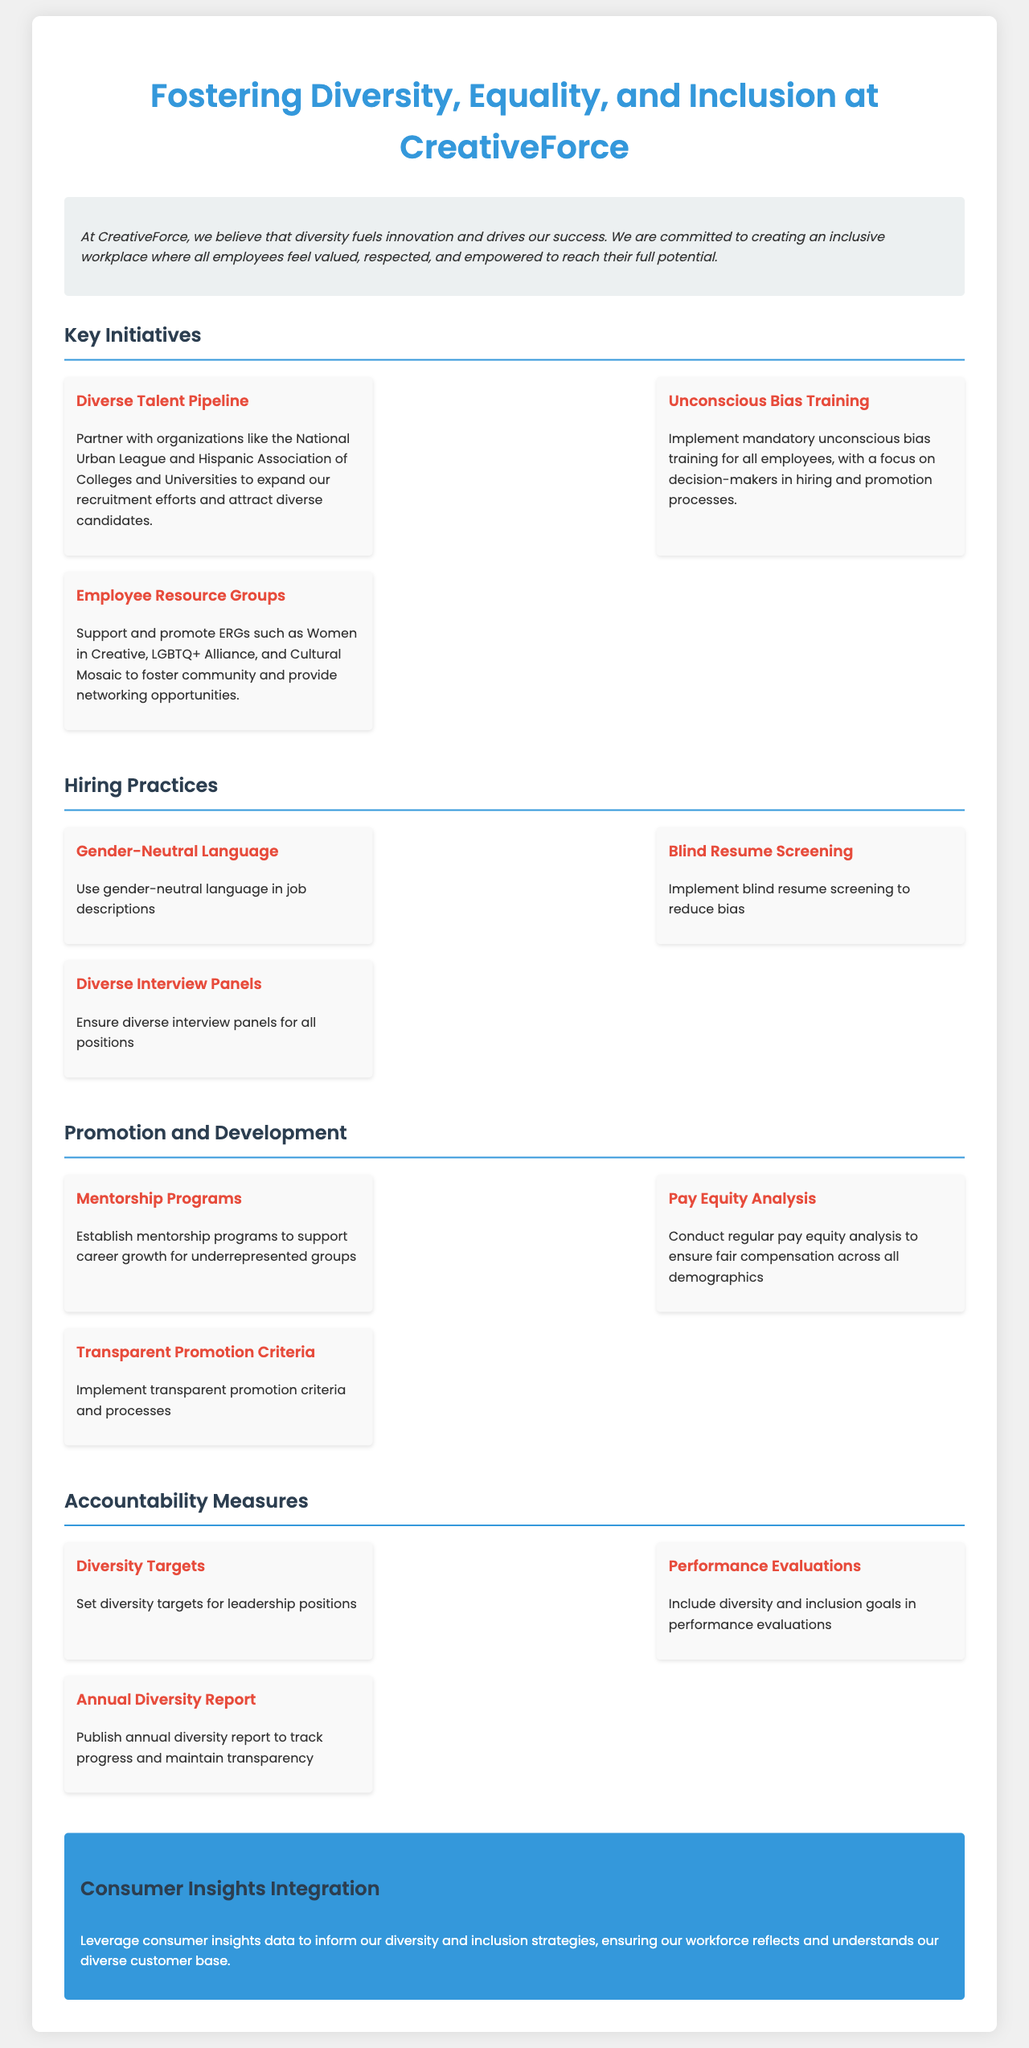What is the mission of CreativeForce? The mission statement outlines the commitment to diversity, inclusivity, and employee empowerment at CreativeForce.
Answer: "Diversity fuels innovation and drives our success." How many key initiatives are listed under Key Initiatives? The document enumerates the various initiatives aimed at promoting diversity, equality, and inclusion.
Answer: Three What is one organization CreativeForce partners with for diverse recruitment? The policy mentions specific organizations that help in expanding recruitment efforts for diverse talent.
Answer: National Urban League What type of training is mandatory for all employees? The document specifies training aimed at addressing bias in decision-making processes.
Answer: Unconscious Bias Training What are Employee Resource Groups abbreviated as? The document refers to community support groups within the organization that foster inclusivity.
Answer: ERGs What is one practice mentioned for hiring? The hiring practices outline strategies to promote equality and reduce bias in the hiring process.
Answer: Blind Resume Screening What does the policy recommend to ensure fair compensation? The document discusses measures to analyze compensation equity across different demographics.
Answer: Pay Equity Analysis What accountability measure includes diversity goals? The policy outlines specific performance evaluations that incorporate diversity and inclusion objectives.
Answer: Performance Evaluations How often does CreativeForce publish its diversity report? The document states the frequency of the reporting aimed at tracking diversity efforts and maintaining transparency.
Answer: Annually 